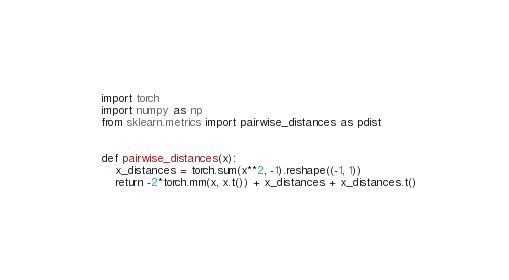<code> <loc_0><loc_0><loc_500><loc_500><_Python_>import torch
import numpy as np
from sklearn.metrics import pairwise_distances as pdist


def pairwise_distances(x):
    x_distances = torch.sum(x**2, -1).reshape((-1, 1))
    return -2*torch.mm(x, x.t()) + x_distances + x_distances.t()

</code> 